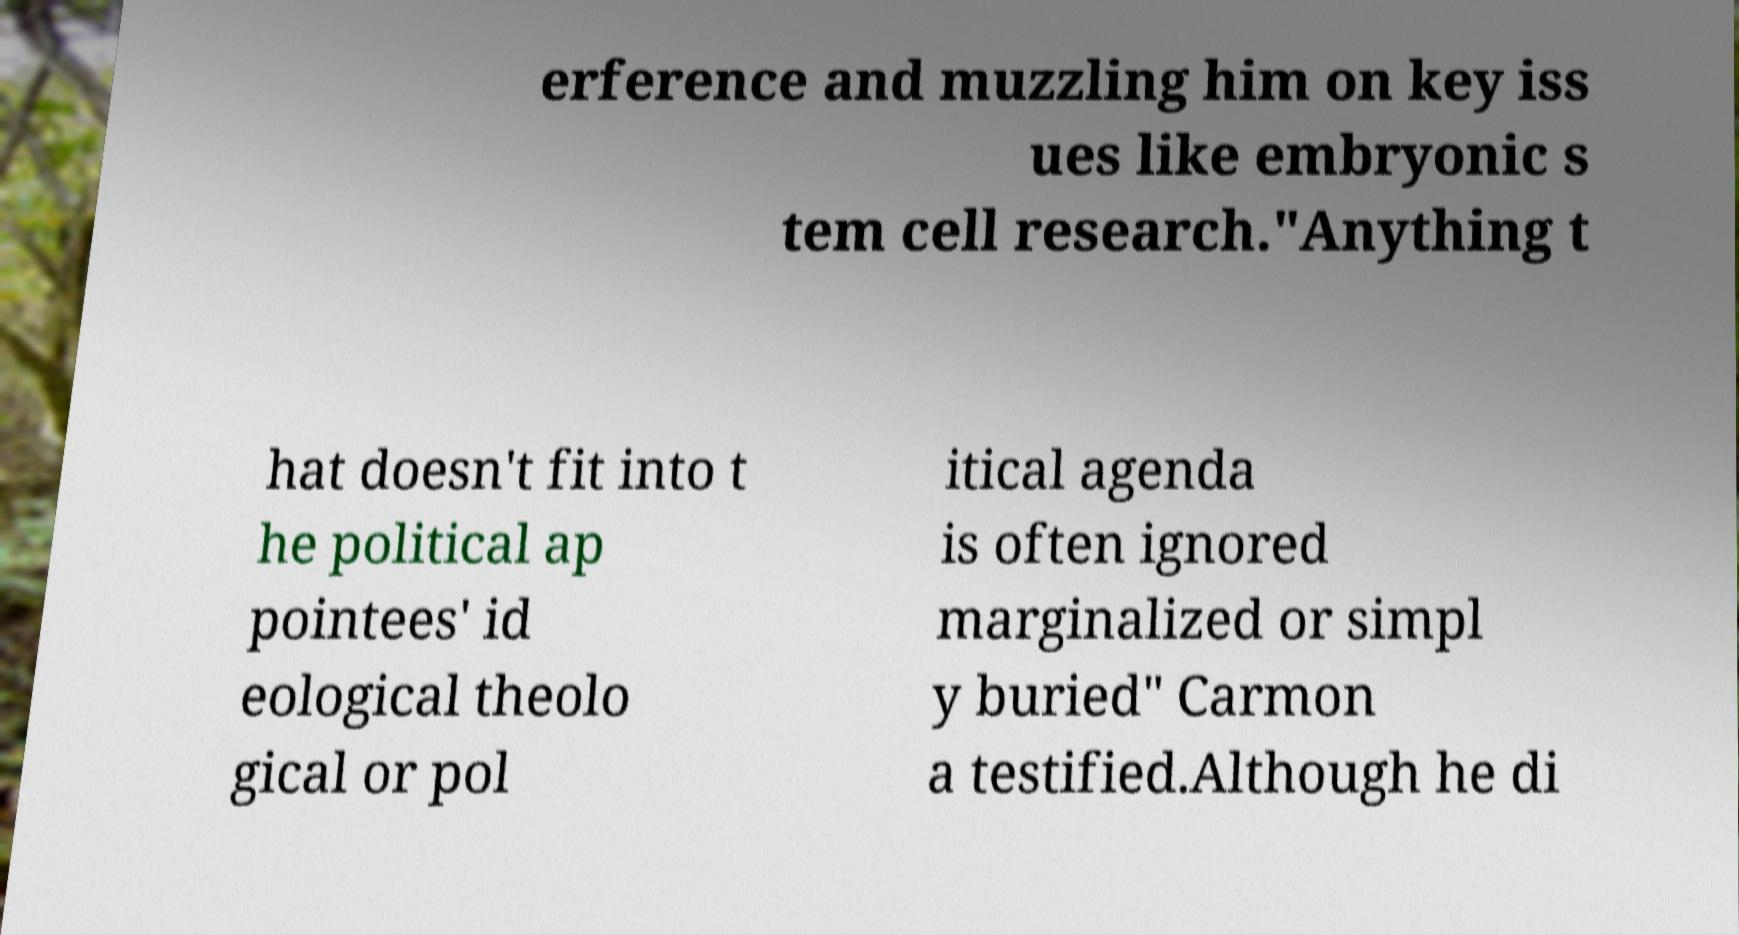Could you assist in decoding the text presented in this image and type it out clearly? erference and muzzling him on key iss ues like embryonic s tem cell research."Anything t hat doesn't fit into t he political ap pointees' id eological theolo gical or pol itical agenda is often ignored marginalized or simpl y buried" Carmon a testified.Although he di 